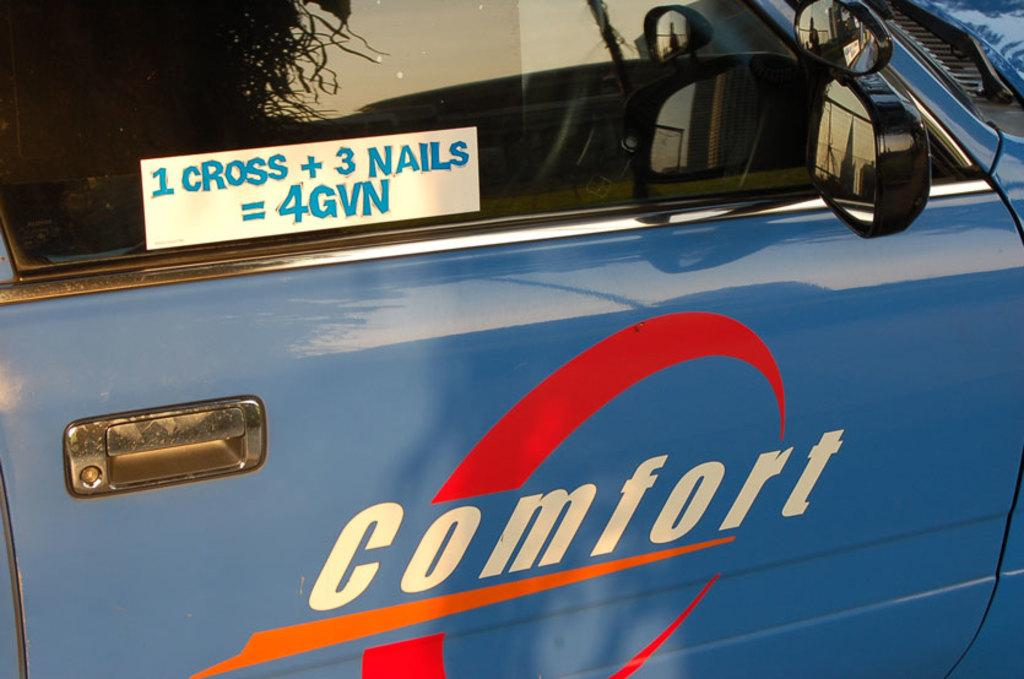What color is the car in the image? The car in the image is blue. Are there any markings or text on the car? Yes, there is text on the car. Can you describe the side view mirrors on the car? Side view mirrors are visible on the right side of the car. Where is the cart used to transport the suit in the image? There is no cart or suit present in the image; it only features a blue color car. 